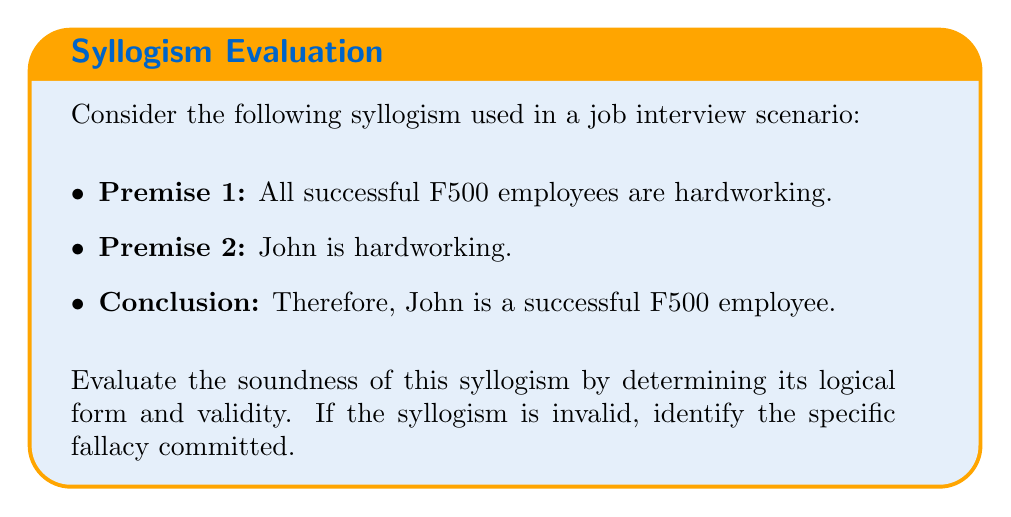Could you help me with this problem? To evaluate the soundness of this syllogism, we need to follow these steps:

1. Identify the logical form of the syllogism:
   Let A = successful F500 employees
       B = hardworking people
       C = John

   The syllogism can be represented as:
   Premise 1: All A are B
   Premise 2: C is B
   Conclusion: C is A

2. Determine the validity of the syllogism:
   This syllogism follows the logical form known as the "fallacy of the undistributed middle." In this form, the middle term (B - hardworking) is not distributed in either premise, meaning it doesn't refer to all members of the set.

3. Analyze the fallacy:
   The fallacy occurs because being hardworking (B) is a characteristic of all successful F500 employees (A), but not all hardworking people are necessarily successful F500 employees. The premises don't provide enough information to conclude that John (C) belongs to the set of successful F500 employees (A).

4. Visual representation:
   We can represent this using a Venn diagram:

   [asy]
   unitsize(1cm);
   
   pair A = (0,0), B = (2,0), C = (1,1.5);
   real r = 1.2;
   
   fill(circle(A,r), lightblue);
   fill(circle(B,r), lightgreen);
   
   draw(circle(A,r), blue);
   draw(circle(B,r), green);
   
   label("A", A, S);
   label("B", B, S);
   label("C", C, N);
   
   dot(C);
   
   label("Successful F500", (-1.5,-1.5));
   label("Hardworking", (3.5,-1.5));
   label("John", (1,2));
   [/asy]

   This diagram shows that while John (C) is in the set of hardworking people (B), we cannot conclude that he is in the set of successful F500 employees (A).

5. Conclusion:
   The syllogism is invalid due to the fallacy of the undistributed middle. While the premises may be true, they don't logically support the conclusion.
Answer: Invalid; fallacy of the undistributed middle 